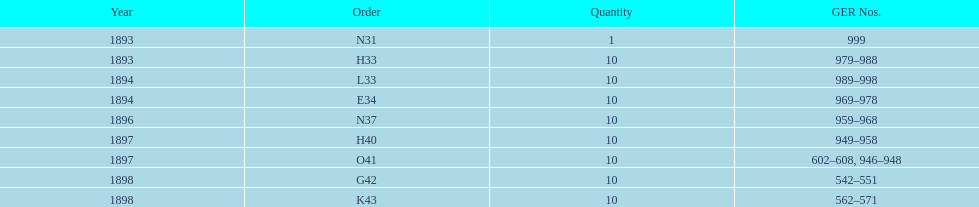How many years are itemized? 5. 